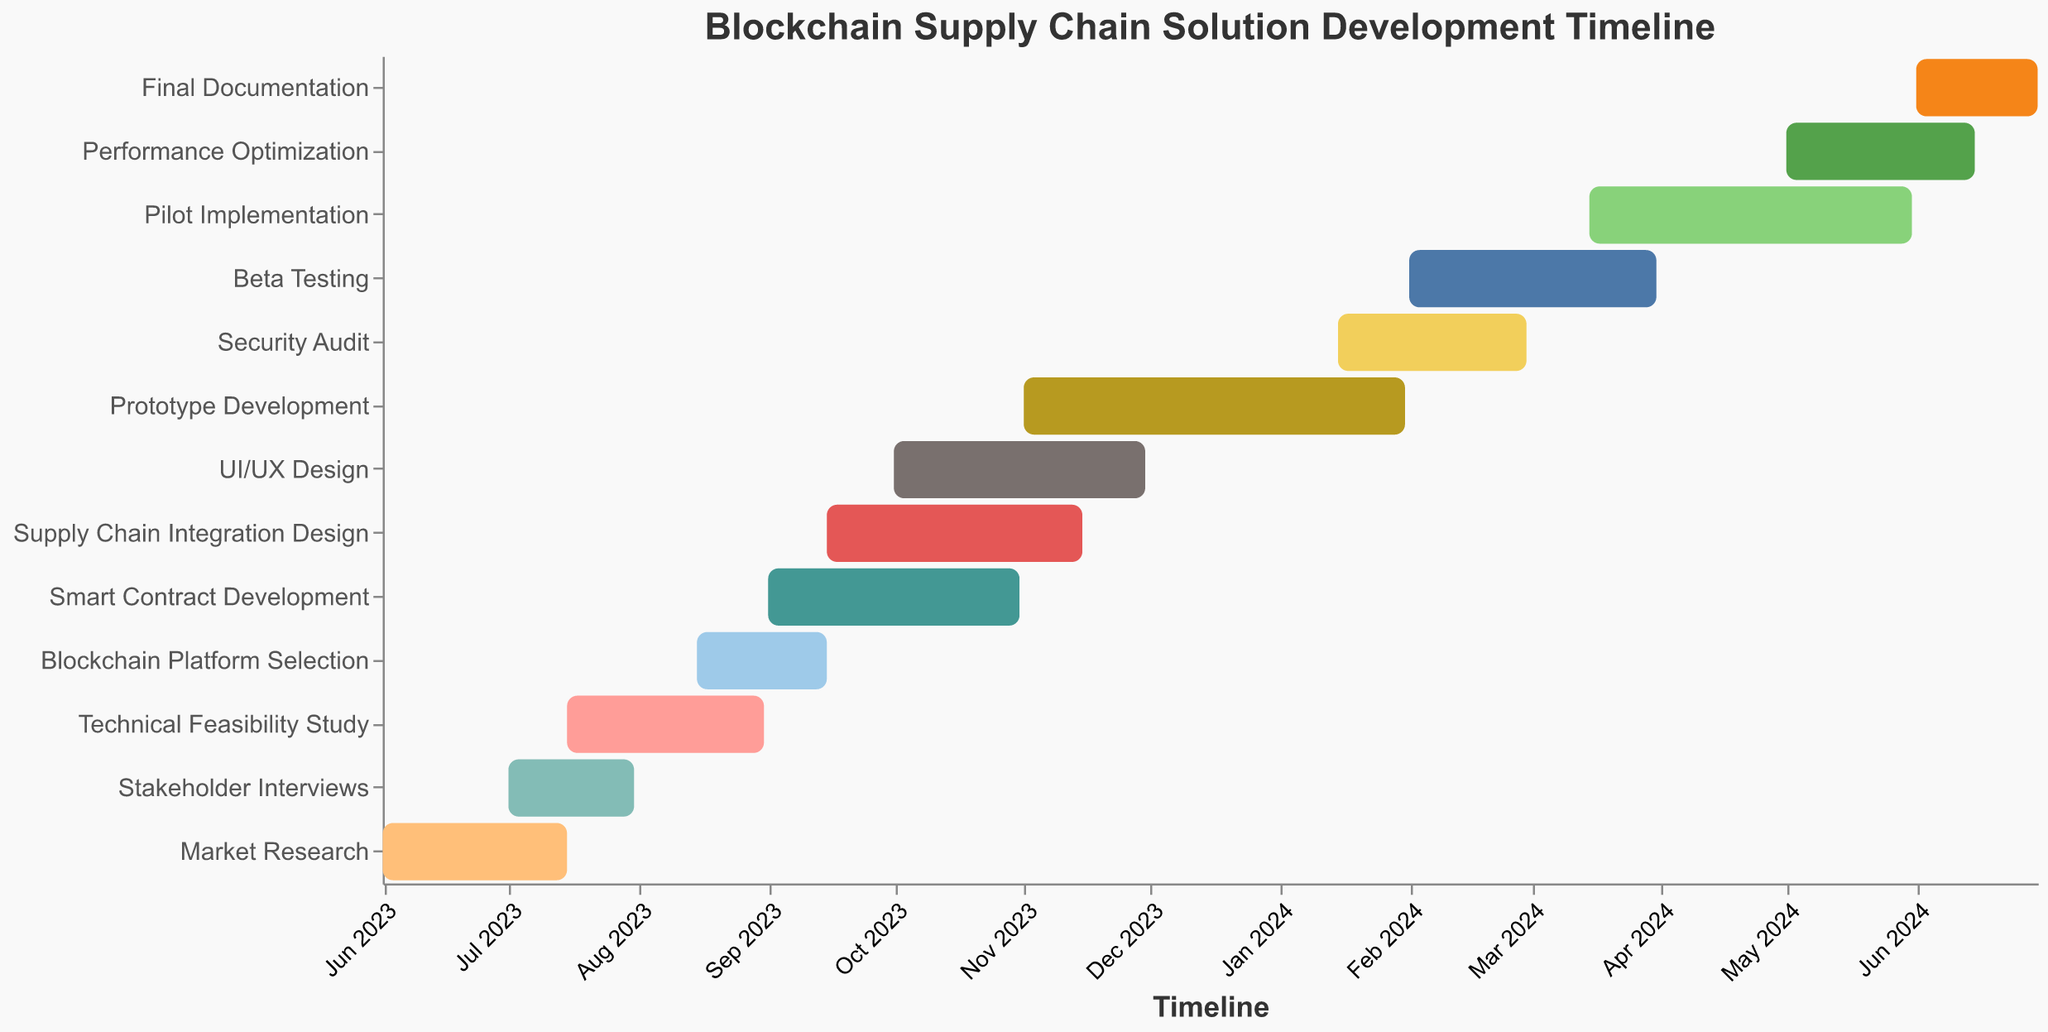What's the title of the Gantt Chart? The title is typically placed at the top of the figure and is plainly visible as an introductory element.
Answer: Blockchain Supply Chain Solution Development Timeline When does the Technical Feasibility Study start and end? To determine this, locate the task "Technical Feasibility Study", then identify the corresponding start and end dates on the timeline.
Answer: 2023-07-15 to 2023-08-31 Which task has the longest duration? To find the task with the longest duration, compare the "Duration (Days)" for each task, spotting the highest value. "Prototype Development" has the longest duration of 92 days.
Answer: Prototype Development Which tasks are scheduled to be completed in November 2023? Check the End Dates of all tasks to identify those that finish in November 2023. "Supply Chain Integration Design" and "UI/UX Design" both end in November 2023.
Answer: Supply Chain Integration Design, UI/UX Design How many days does the Security Audit take? Read the "Duration (Days)" value next to the "Security Audit" task.
Answer: 45 days What are the start and end dates for the Smart Contract Development? Locate the task named "Smart Contract Development" on the timeline and read its start and end dates from the chart.
Answer: 2023-09-01 to 2023-10-31 What is the total duration of Beta Testing and Pilot Implementation combined? Add the duration of "Beta Testing" (60 days) and "Pilot Implementation" (77 days) to get the total. 60 + 77 = 137 days.
Answer: 137 days Which task starts immediately after the Technical Feasibility Study ends? Compare the end date of "Technical Feasibility Study" (2023-08-31) with the start dates of other tasks, identifying the one that starts soonest after this date. "Blockchain Platform Selection" starts on 2023-08-15.
Answer: Blockchain Platform Selection When does the final task on the timeline end? Identify the last task on the timeline, "Final Documentation", and note its end date.
Answer: 2024-06-30 How many tasks overlap with the Prototype Development phase? Identify the tasks whose start and end dates overlap with "Prototype Development" (2023-11-01 to 2024-01-31). Overlapping tasks include "UI/UX Design," "Supply Chain Integration Design," and "Security Audit".
Answer: 3 tasks 